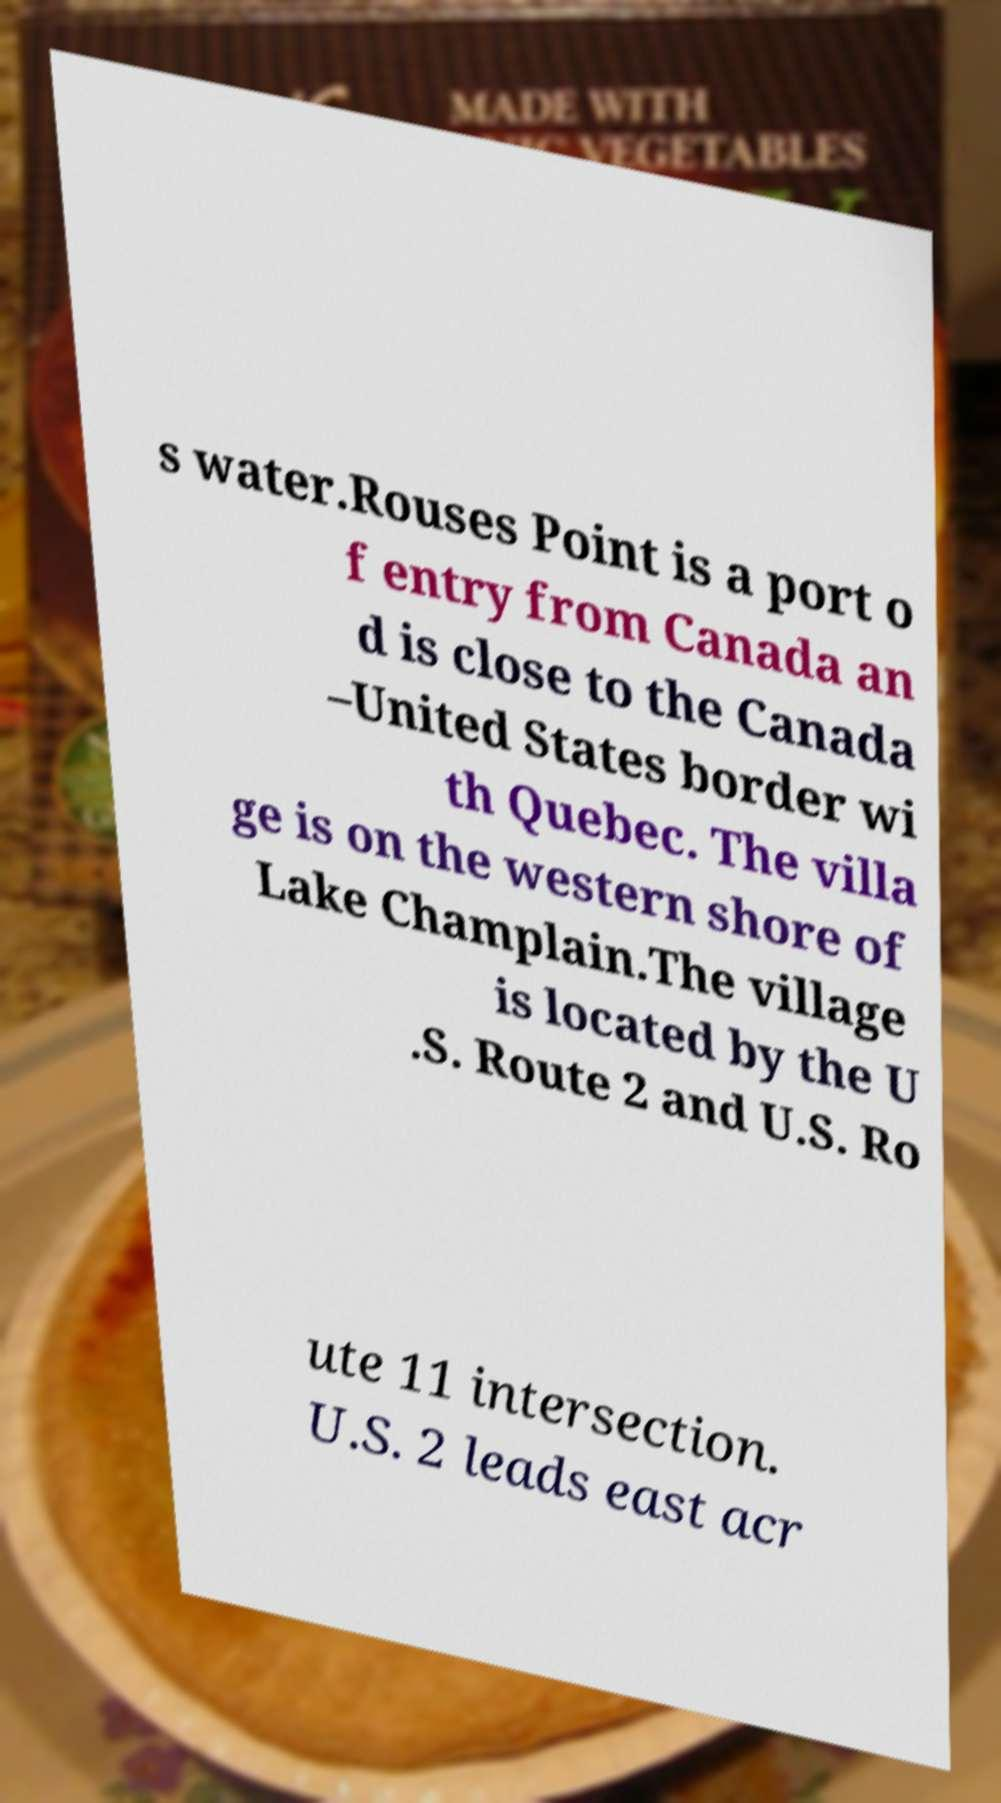Could you extract and type out the text from this image? s water.Rouses Point is a port o f entry from Canada an d is close to the Canada –United States border wi th Quebec. The villa ge is on the western shore of Lake Champlain.The village is located by the U .S. Route 2 and U.S. Ro ute 11 intersection. U.S. 2 leads east acr 